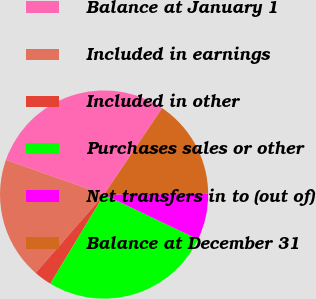Convert chart. <chart><loc_0><loc_0><loc_500><loc_500><pie_chart><fcel>Balance at January 1<fcel>Included in earnings<fcel>Included in other<fcel>Purchases sales or other<fcel>Net transfers in to (out of)<fcel>Balance at December 31<nl><fcel>29.02%<fcel>18.99%<fcel>2.77%<fcel>26.55%<fcel>7.19%<fcel>15.49%<nl></chart> 